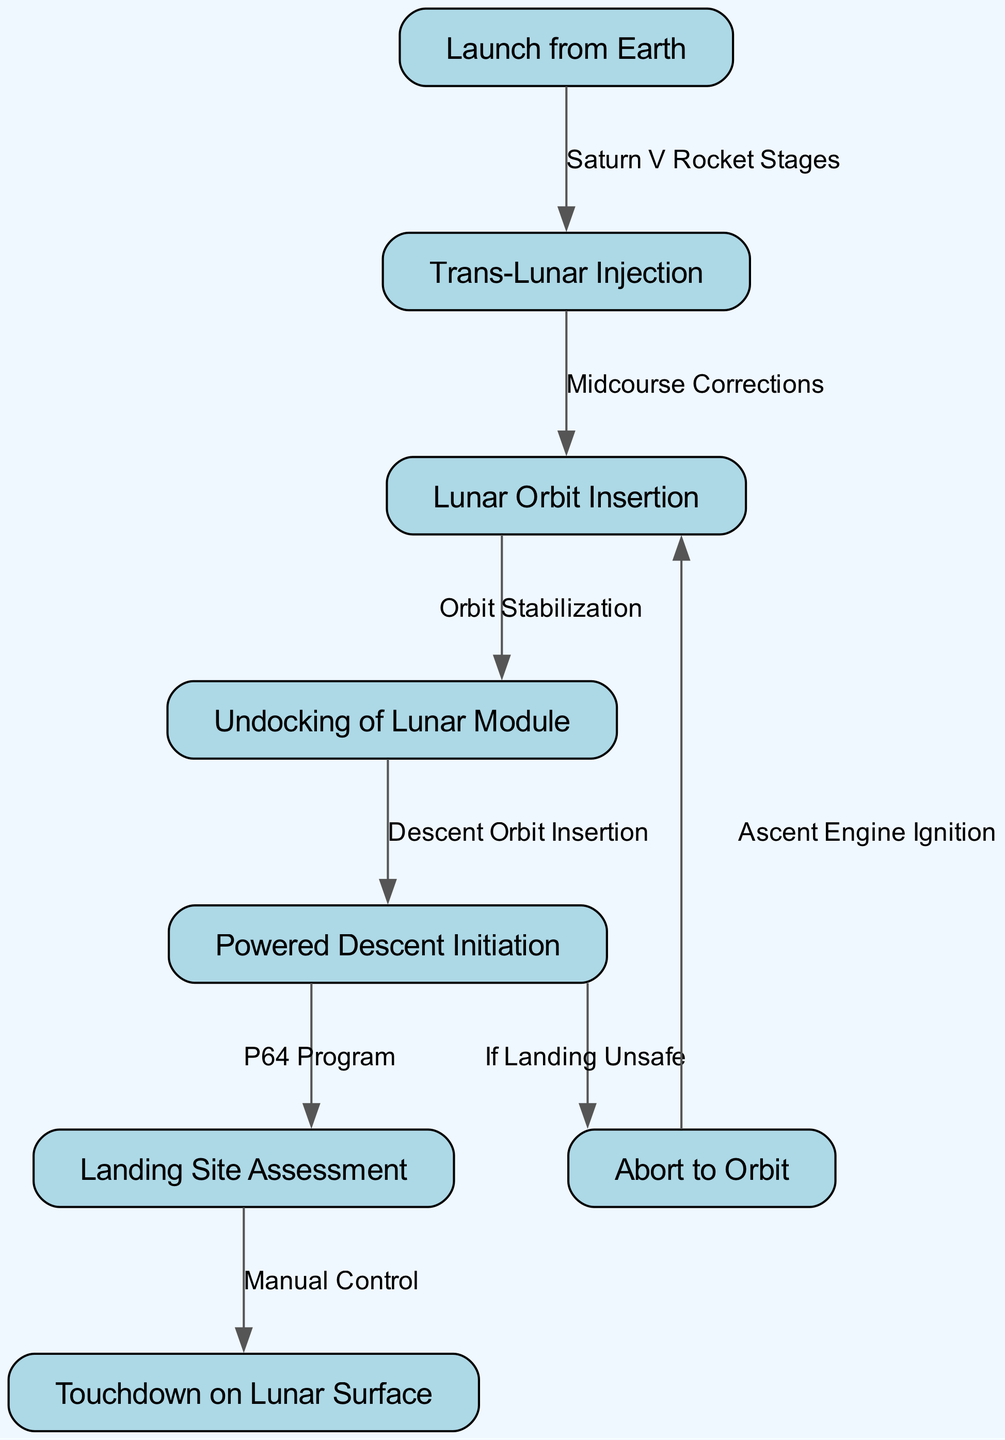What is the first step in the lunar landing procedure? The diagram starts with the node labeled "Launch from Earth," which is the initial action in the sequence for the lunar landing procedure.
Answer: Launch from Earth How many nodes are there in the diagram? By counting the distinct nodes shown in the diagram, we identify there are eight nodes representing different steps in the lunar landing procedure.
Answer: 8 What text describes the process from "Trans-Lunar Injection" to "Lunar Orbit Insertion"? The edge between "Trans-Lunar Injection" and "Lunar Orbit Insertion" is labeled "Midcourse Corrections," indicating this is the description of the transition between these two nodes.
Answer: Midcourse Corrections Which action is initiated after "Powered Descent Initiation"? After "Powered Descent Initiation," the next action is "Landing Site Assessment," as shown by the directional edge linking these two nodes.
Answer: Landing Site Assessment What happens if the landing is deemed unsafe during the descent? The diagram indicates that if landing is unsafe during the descent, the procedure leads to the node "Abort to Orbit," which offers a contingency plan.
Answer: Abort to Orbit How is the "Touchdown on Lunar Surface" achieved? The "Touchdown on Lunar Surface" is reached after "Landing Site Assessment," which is performed using "Manual Control," as per the direct connection from one process to the next.
Answer: Manual Control What edge connects "Abort to Orbit" back to "Lunar Orbit Insertion"? The edge labeled "Ascent Engine Ignition" establishes a transition from "Abort to Orbit" back to "Lunar Orbit Insertion," indicating the procedure for a safe return to a previous stage.
Answer: Ascent Engine Ignition What is the link between "Undocking of Lunar Module" and "Powered Descent Initiation"? The "Descent Orbit Insertion" edge visually demonstrates the process connecting "Undocking of Lunar Module" to "Powered Descent Initiation."
Answer: Descent Orbit Insertion 